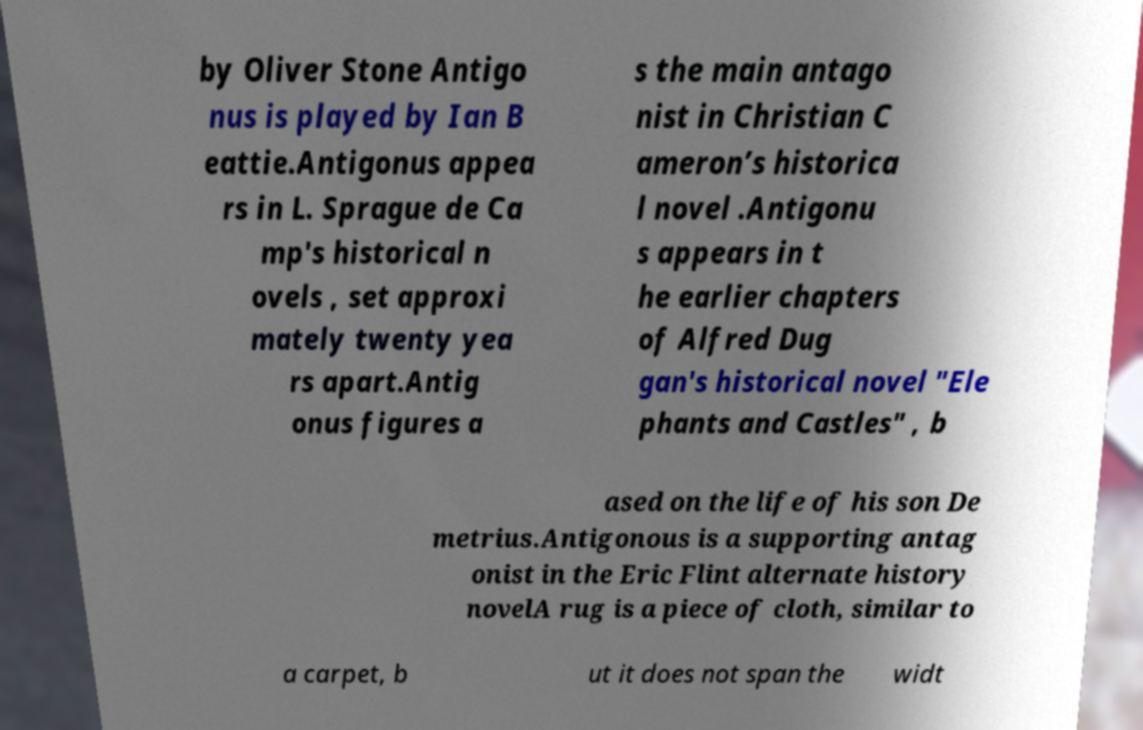What messages or text are displayed in this image? I need them in a readable, typed format. by Oliver Stone Antigo nus is played by Ian B eattie.Antigonus appea rs in L. Sprague de Ca mp's historical n ovels , set approxi mately twenty yea rs apart.Antig onus figures a s the main antago nist in Christian C ameron’s historica l novel .Antigonu s appears in t he earlier chapters of Alfred Dug gan's historical novel "Ele phants and Castles" , b ased on the life of his son De metrius.Antigonous is a supporting antag onist in the Eric Flint alternate history novelA rug is a piece of cloth, similar to a carpet, b ut it does not span the widt 